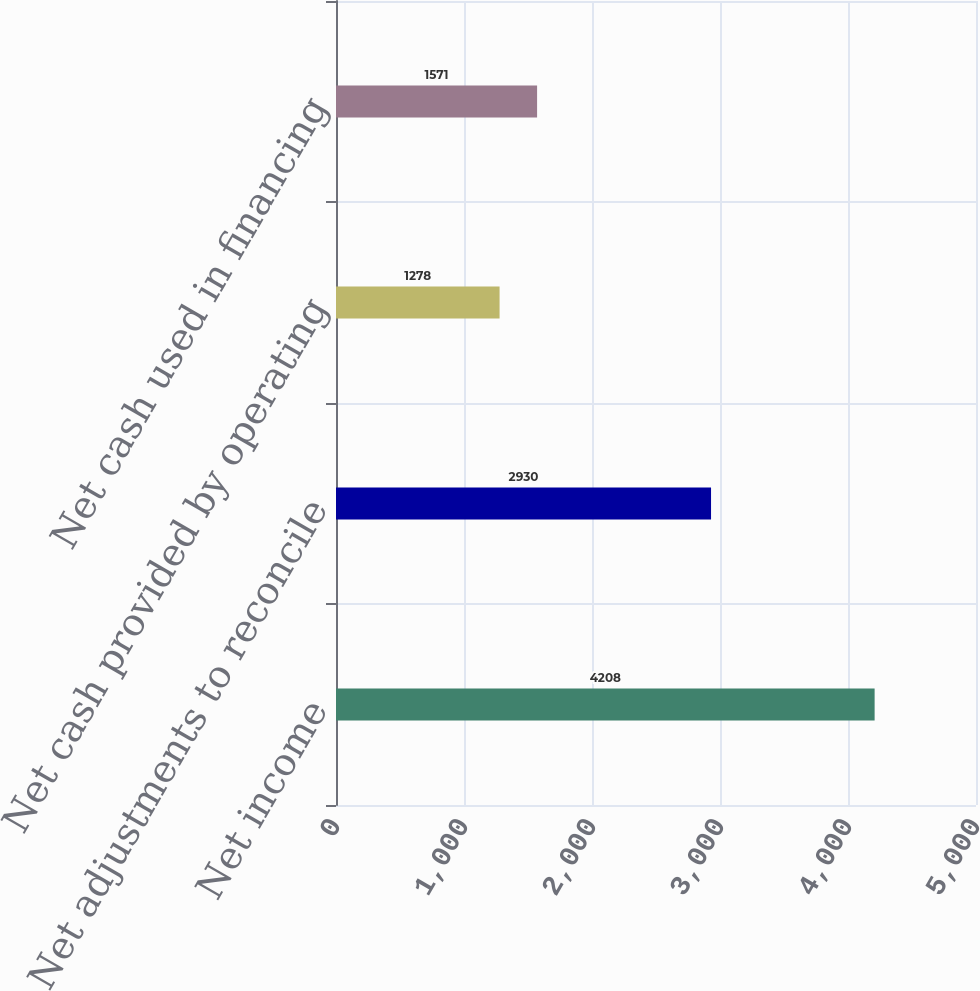Convert chart. <chart><loc_0><loc_0><loc_500><loc_500><bar_chart><fcel>Net income<fcel>Net adjustments to reconcile<fcel>Net cash provided by operating<fcel>Net cash used in financing<nl><fcel>4208<fcel>2930<fcel>1278<fcel>1571<nl></chart> 